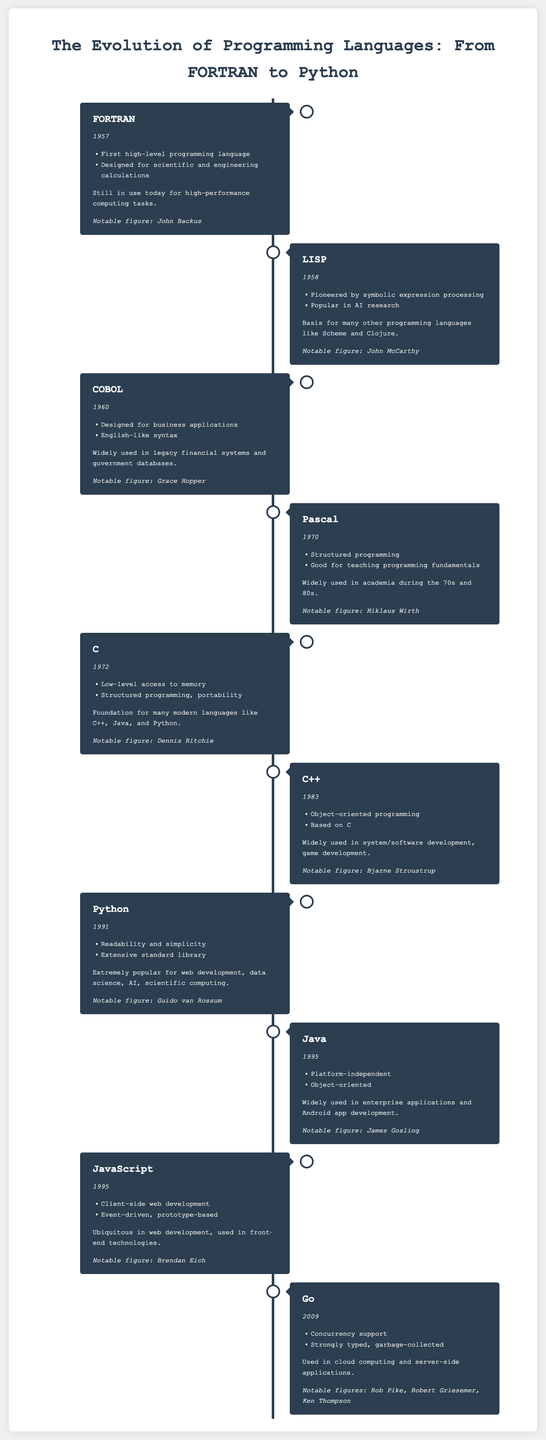What year was FORTRAN created? FORTRAN was created in 1957, as indicated in the timeline of programming languages.
Answer: 1957 Who is associated with the creation of LISP? LISP was pioneered by John McCarthy, a notable figure mentioned in the document.
Answer: John McCarthy Which language is designed for scientific and engineering calculations? The timeline specifies that FORTRAN is designed for scientific and engineering calculations.
Answer: FORTRAN What significant feature was introduced with the C++ language? C++ introduced object-oriented programming, a key feature listed in the programming language description.
Answer: Object-oriented programming Which programming language is widely used in data science? Python is described as extremely popular for web development, data science, and scientific computing.
Answer: Python What programming language was developed in 1995 that is platform-independent? The document indicates that Java, created in 1995, is platform-independent.
Answer: Java What is the primary focus of the programming language Go? Go is highlighted for its concurrency support, a major feature noted in the timeline.
Answer: Concurrency support Which notable figure developed Python? Guido van Rossum is mentioned as the notable figure associated with the creation of Python.
Answer: Guido van Rossum Which language was developed as a response to the need for business applications? The timeline mentions COBOL was designed for business applications.
Answer: COBOL 